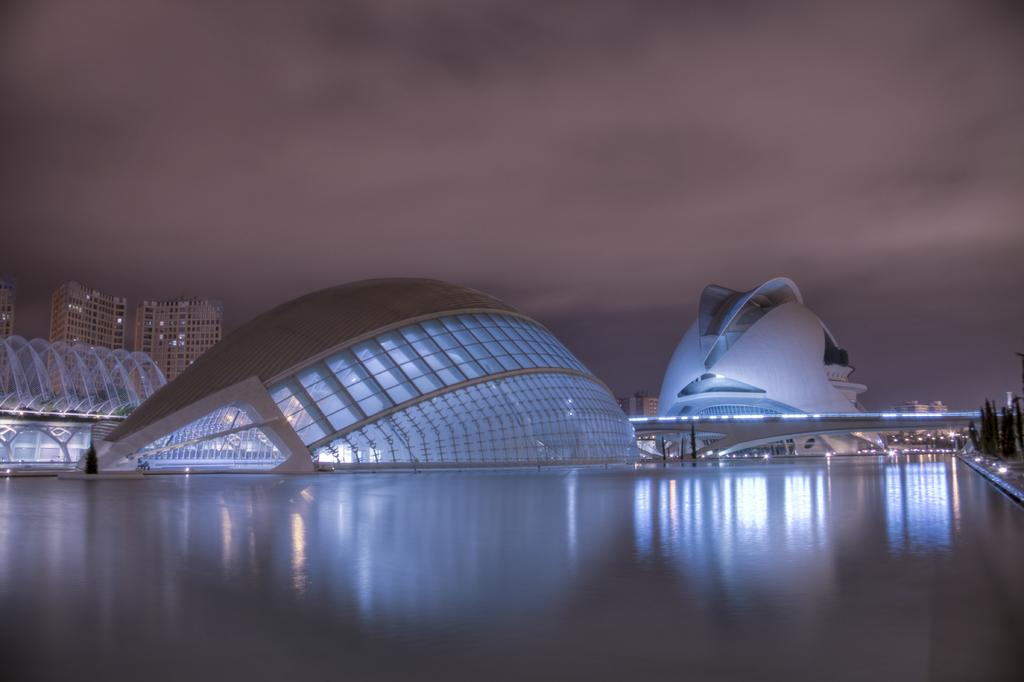What type of structures can be seen in the image? There are buildings in the image. What natural elements are present in the image? There are trees in the image. What man-made feature connects two areas in the image? There is a bridge in the image. What natural element is flowing in the image? There is water visible in the image. What artificial light sources are present in the image? There are lights in the image. What can be seen in the background of the image? The sky is visible in the background of the image. What atmospheric feature is present in the sky? There are clouds in the sky. Where is the flower located in the image? There is no flower present in the image. What type of furniture can be seen on the bridge in the image? There is no furniture, specifically a desk, present on the bridge in the image. 